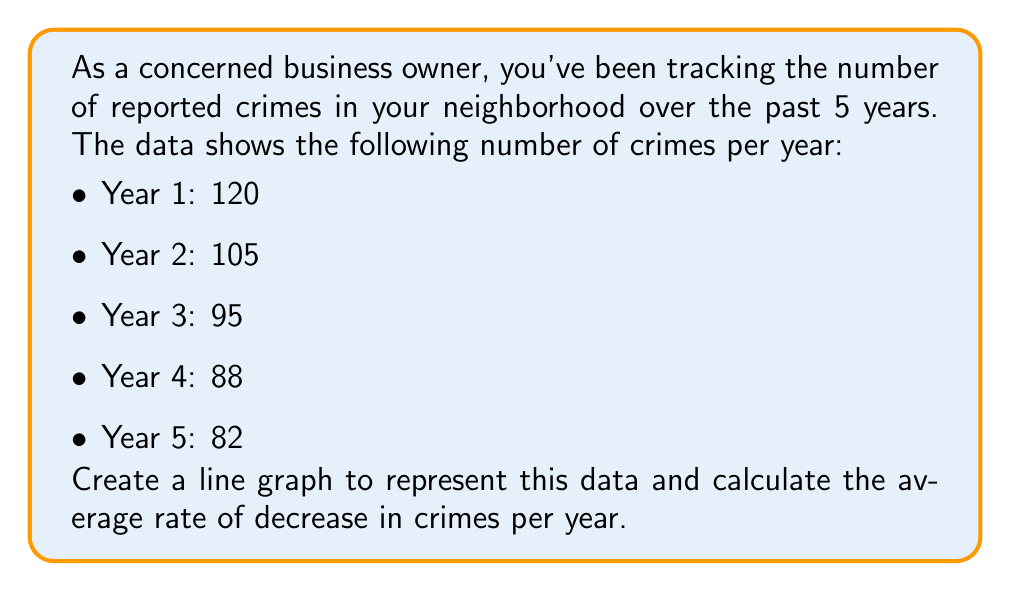What is the answer to this math problem? To solve this problem, we'll follow these steps:

1. Create a line graph:
   [asy]
   import graph;
   size(200,150);
   
   xaxis("Year",Ticks(Label(),1));
   yaxis("Number of Crimes",Ticks(Label(),20));
   
   real[] x = {1,2,3,4,5};
   real[] y = {120,105,95,88,82};
   
   draw(graph(x,y),red);
   
   for(int i=0; i < 5; ++i) {
     dot((x[i],y[i]));
   }
   [/asy]

2. Calculate the total decrease in crimes:
   $\text{Total decrease} = \text{Year 1 crimes} - \text{Year 5 crimes}$
   $\text{Total decrease} = 120 - 82 = 38$ crimes

3. Calculate the average rate of decrease per year:
   $\text{Average rate of decrease} = \frac{\text{Total decrease}}{\text{Number of years - 1}}$
   $\text{Average rate of decrease} = \frac{38}{5-1} = \frac{38}{4} = 9.5$ crimes per year

The line graph shows a clear downward trend in the number of reported crimes over the 5-year period. The slope of the line represents the rate of decrease, which we've calculated to be an average of 9.5 crimes per year.
Answer: The average rate of decrease in crimes per year is 9.5 crimes. 